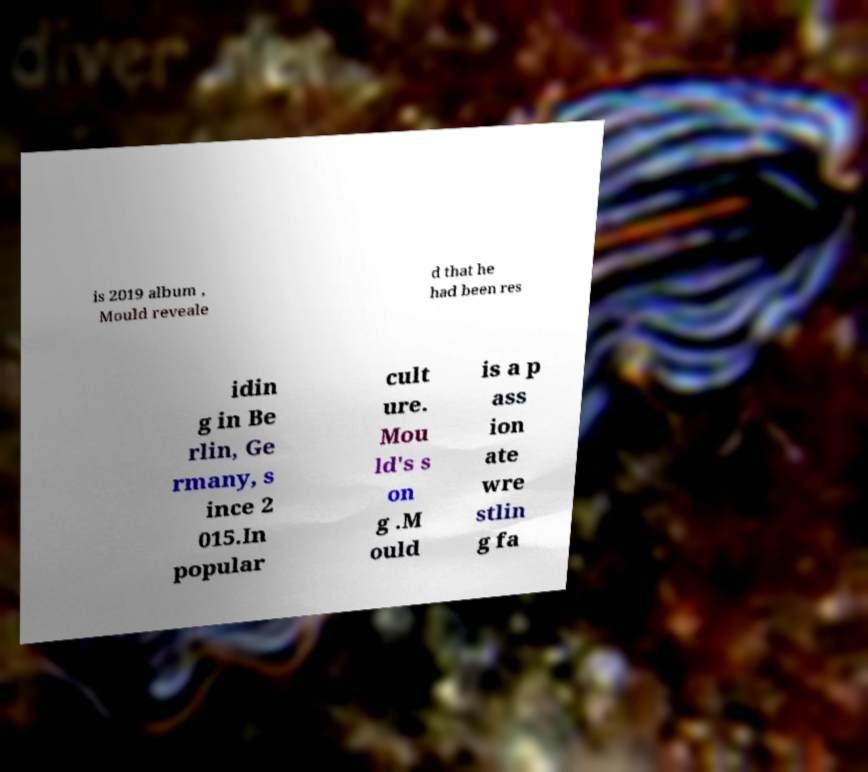Can you read and provide the text displayed in the image?This photo seems to have some interesting text. Can you extract and type it out for me? is 2019 album , Mould reveale d that he had been res idin g in Be rlin, Ge rmany, s ince 2 015.In popular cult ure. Mou ld's s on g .M ould is a p ass ion ate wre stlin g fa 